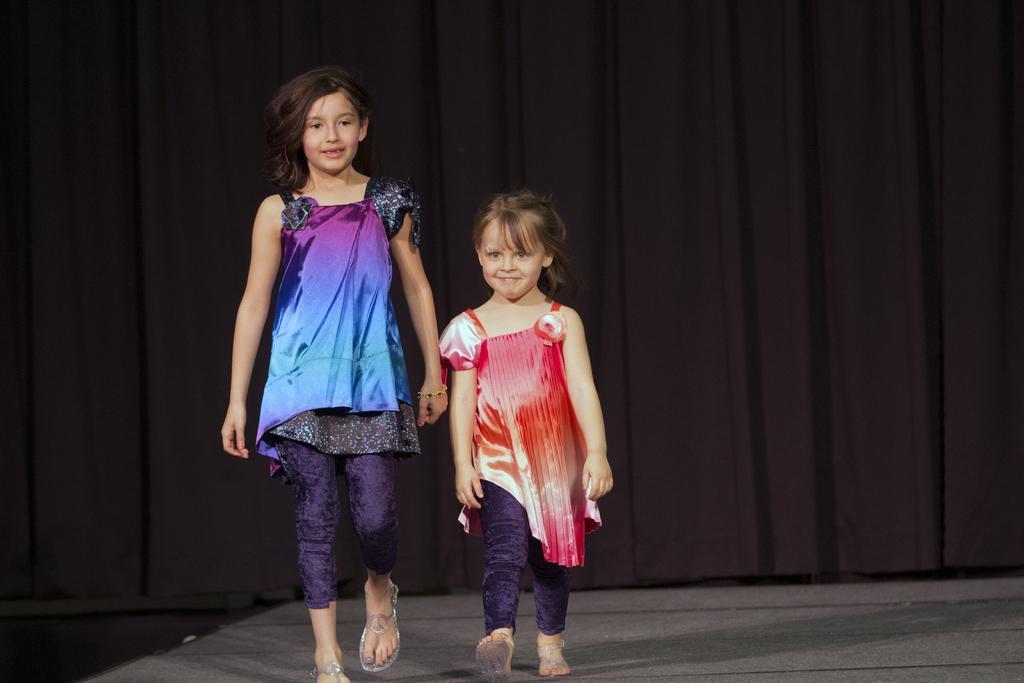Could you give a brief overview of what you see in this image? This picture seems to be clicked inside the hall. On the left we can see the two girls wearing dresses and walking on the floor. In the background we can see the black color curtains. 